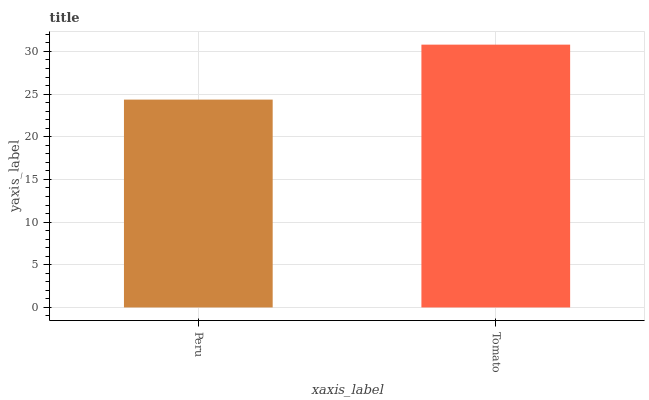Is Tomato the minimum?
Answer yes or no. No. Is Tomato greater than Peru?
Answer yes or no. Yes. Is Peru less than Tomato?
Answer yes or no. Yes. Is Peru greater than Tomato?
Answer yes or no. No. Is Tomato less than Peru?
Answer yes or no. No. Is Tomato the high median?
Answer yes or no. Yes. Is Peru the low median?
Answer yes or no. Yes. Is Peru the high median?
Answer yes or no. No. Is Tomato the low median?
Answer yes or no. No. 